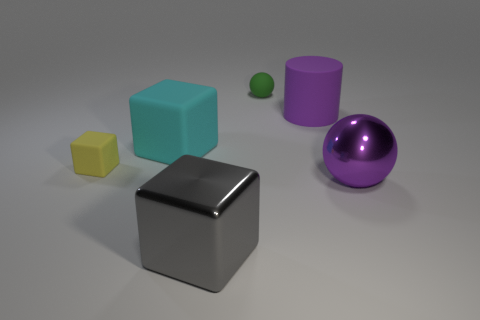Add 3 purple shiny objects. How many objects exist? 9 Subtract all balls. How many objects are left? 4 Subtract all large purple spheres. Subtract all gray metallic cubes. How many objects are left? 4 Add 3 big gray blocks. How many big gray blocks are left? 4 Add 4 big purple cylinders. How many big purple cylinders exist? 5 Subtract 0 cyan cylinders. How many objects are left? 6 